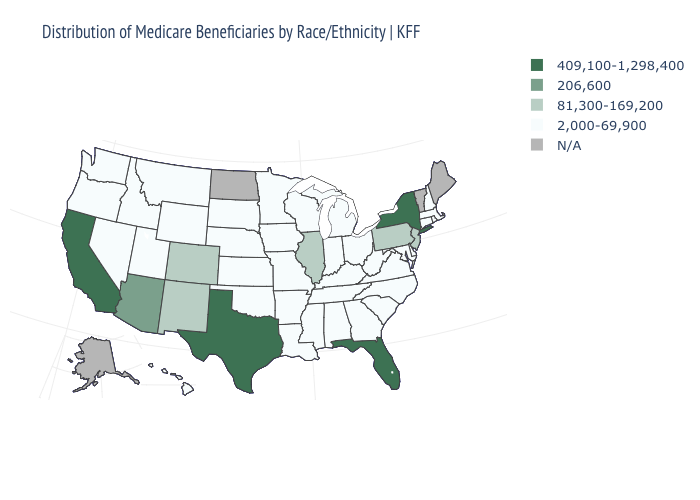Which states have the lowest value in the USA?
Quick response, please. Alabama, Arkansas, Connecticut, Delaware, Georgia, Hawaii, Idaho, Indiana, Iowa, Kansas, Kentucky, Louisiana, Maryland, Massachusetts, Michigan, Minnesota, Mississippi, Missouri, Montana, Nebraska, Nevada, New Hampshire, North Carolina, Ohio, Oklahoma, Oregon, Rhode Island, South Carolina, South Dakota, Tennessee, Utah, Virginia, Washington, West Virginia, Wisconsin, Wyoming. What is the value of Virginia?
Write a very short answer. 2,000-69,900. Which states have the lowest value in the USA?
Be succinct. Alabama, Arkansas, Connecticut, Delaware, Georgia, Hawaii, Idaho, Indiana, Iowa, Kansas, Kentucky, Louisiana, Maryland, Massachusetts, Michigan, Minnesota, Mississippi, Missouri, Montana, Nebraska, Nevada, New Hampshire, North Carolina, Ohio, Oklahoma, Oregon, Rhode Island, South Carolina, South Dakota, Tennessee, Utah, Virginia, Washington, West Virginia, Wisconsin, Wyoming. Name the states that have a value in the range 206,600?
Answer briefly. Arizona. What is the value of New York?
Quick response, please. 409,100-1,298,400. Does Maryland have the lowest value in the USA?
Quick response, please. Yes. Name the states that have a value in the range 2,000-69,900?
Short answer required. Alabama, Arkansas, Connecticut, Delaware, Georgia, Hawaii, Idaho, Indiana, Iowa, Kansas, Kentucky, Louisiana, Maryland, Massachusetts, Michigan, Minnesota, Mississippi, Missouri, Montana, Nebraska, Nevada, New Hampshire, North Carolina, Ohio, Oklahoma, Oregon, Rhode Island, South Carolina, South Dakota, Tennessee, Utah, Virginia, Washington, West Virginia, Wisconsin, Wyoming. Which states have the lowest value in the USA?
Give a very brief answer. Alabama, Arkansas, Connecticut, Delaware, Georgia, Hawaii, Idaho, Indiana, Iowa, Kansas, Kentucky, Louisiana, Maryland, Massachusetts, Michigan, Minnesota, Mississippi, Missouri, Montana, Nebraska, Nevada, New Hampshire, North Carolina, Ohio, Oklahoma, Oregon, Rhode Island, South Carolina, South Dakota, Tennessee, Utah, Virginia, Washington, West Virginia, Wisconsin, Wyoming. How many symbols are there in the legend?
Be succinct. 5. Name the states that have a value in the range 409,100-1,298,400?
Short answer required. California, Florida, New York, Texas. Name the states that have a value in the range N/A?
Concise answer only. Alaska, Maine, North Dakota, Vermont. Name the states that have a value in the range 409,100-1,298,400?
Concise answer only. California, Florida, New York, Texas. Is the legend a continuous bar?
Keep it brief. No. Name the states that have a value in the range N/A?
Keep it brief. Alaska, Maine, North Dakota, Vermont. 